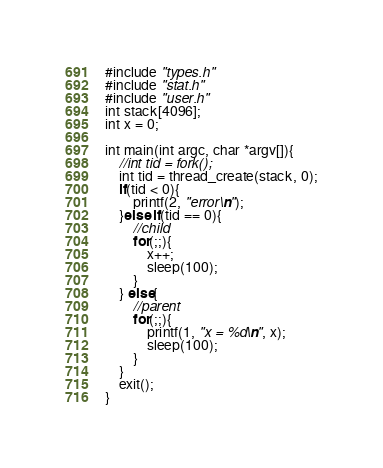Convert code to text. <code><loc_0><loc_0><loc_500><loc_500><_C_>#include "types.h"
#include "stat.h"
#include "user.h"
int stack[4096];
int x = 0;

int main(int argc, char *argv[]){
    //int tid = fork();
    int tid = thread_create(stack, 0);
    if(tid < 0){
        printf(2, "error\n");
    }else if(tid == 0){
        //child
        for(;;){
            x++;
            sleep(100);
        }
    } else{
        //parent
        for(;;){
            printf(1, "x = %d\n", x);
            sleep(100);
        }
    }
    exit();
}</code> 